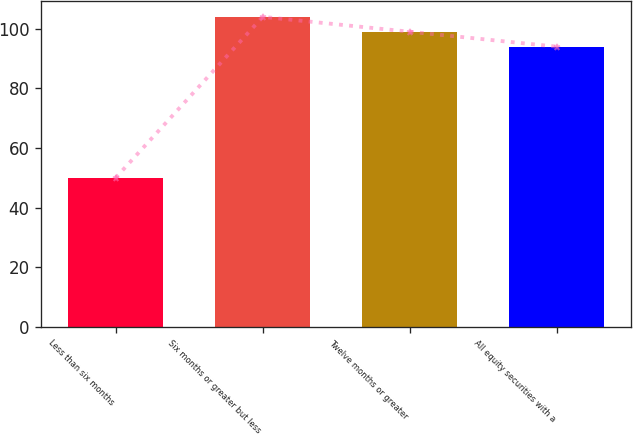Convert chart. <chart><loc_0><loc_0><loc_500><loc_500><bar_chart><fcel>Less than six months<fcel>Six months or greater but less<fcel>Twelve months or greater<fcel>All equity securities with a<nl><fcel>50<fcel>104<fcel>99<fcel>94<nl></chart> 